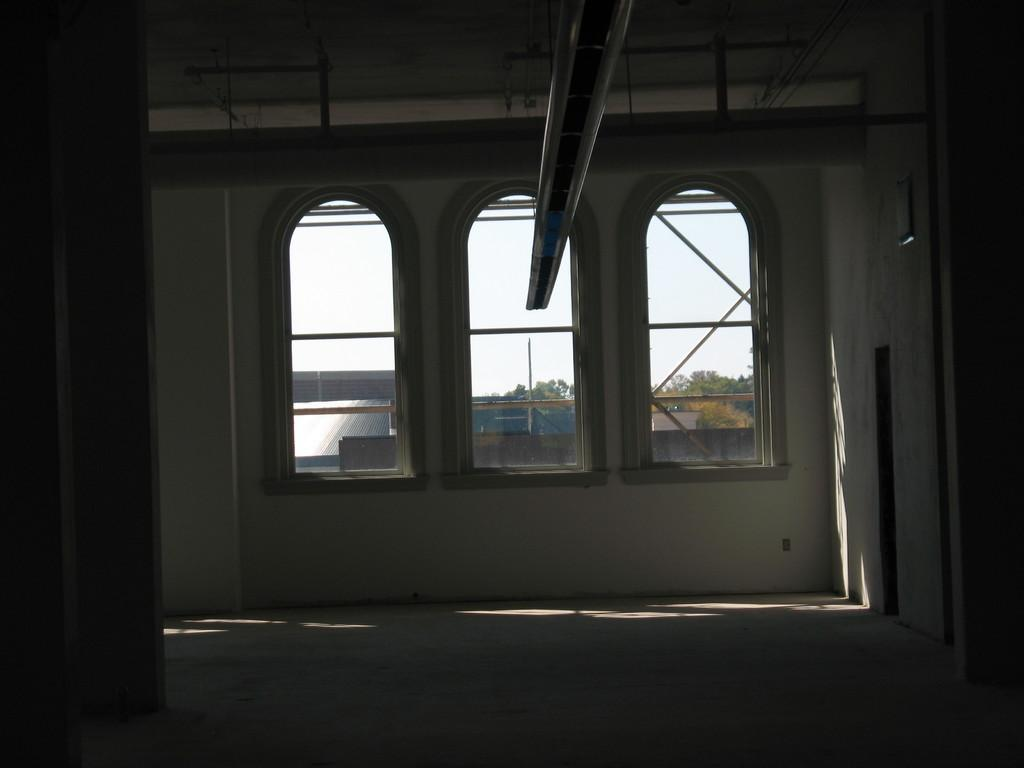What type of view is shown in the image? The image is an inside view of a building. What feature of the building is visible in the image? There are windows in the building. What material is used for the windows? The windows have glass panes. What can be seen through the glass panes? Poles are visible through the glass panes. What type of natural environment is visible in the image? There are trees in the image. What type of man-made structures are visible in the image? There are buildings in the image. What time of day is it in the image, and what type of crime is being committed? The time of day and any crime being committed are not visible or mentioned in the image. 